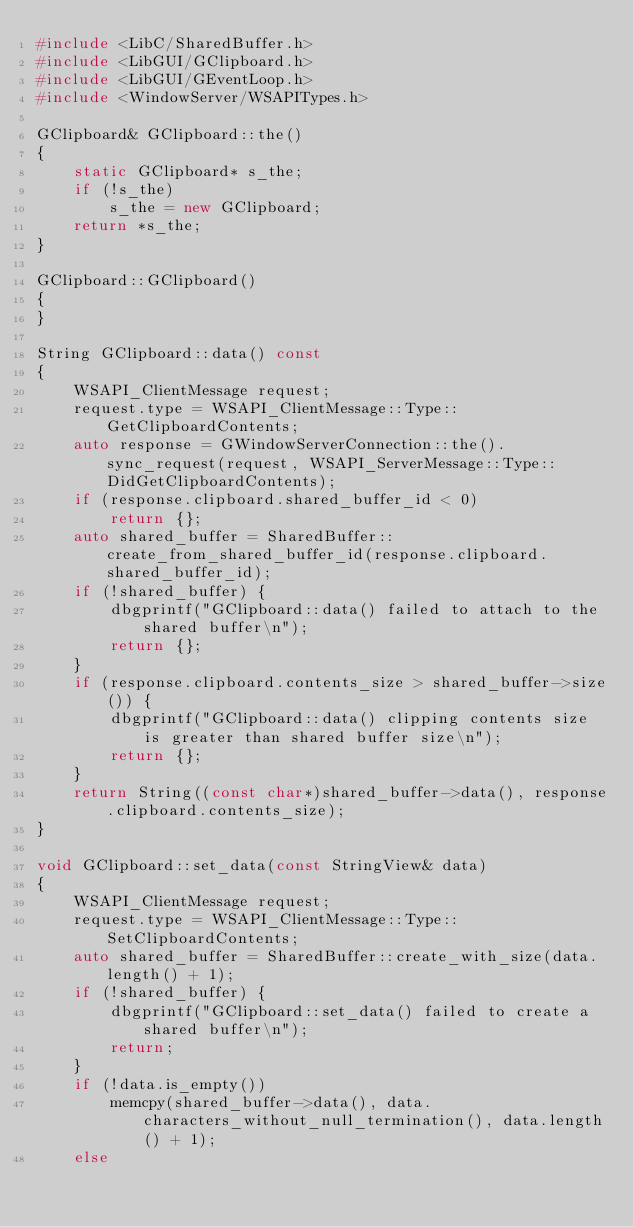Convert code to text. <code><loc_0><loc_0><loc_500><loc_500><_C++_>#include <LibC/SharedBuffer.h>
#include <LibGUI/GClipboard.h>
#include <LibGUI/GEventLoop.h>
#include <WindowServer/WSAPITypes.h>

GClipboard& GClipboard::the()
{
    static GClipboard* s_the;
    if (!s_the)
        s_the = new GClipboard;
    return *s_the;
}

GClipboard::GClipboard()
{
}

String GClipboard::data() const
{
    WSAPI_ClientMessage request;
    request.type = WSAPI_ClientMessage::Type::GetClipboardContents;
    auto response = GWindowServerConnection::the().sync_request(request, WSAPI_ServerMessage::Type::DidGetClipboardContents);
    if (response.clipboard.shared_buffer_id < 0)
        return {};
    auto shared_buffer = SharedBuffer::create_from_shared_buffer_id(response.clipboard.shared_buffer_id);
    if (!shared_buffer) {
        dbgprintf("GClipboard::data() failed to attach to the shared buffer\n");
        return {};
    }
    if (response.clipboard.contents_size > shared_buffer->size()) {
        dbgprintf("GClipboard::data() clipping contents size is greater than shared buffer size\n");
        return {};
    }
    return String((const char*)shared_buffer->data(), response.clipboard.contents_size);
}

void GClipboard::set_data(const StringView& data)
{
    WSAPI_ClientMessage request;
    request.type = WSAPI_ClientMessage::Type::SetClipboardContents;
    auto shared_buffer = SharedBuffer::create_with_size(data.length() + 1);
    if (!shared_buffer) {
        dbgprintf("GClipboard::set_data() failed to create a shared buffer\n");
        return;
    }
    if (!data.is_empty())
        memcpy(shared_buffer->data(), data.characters_without_null_termination(), data.length() + 1);
    else</code> 